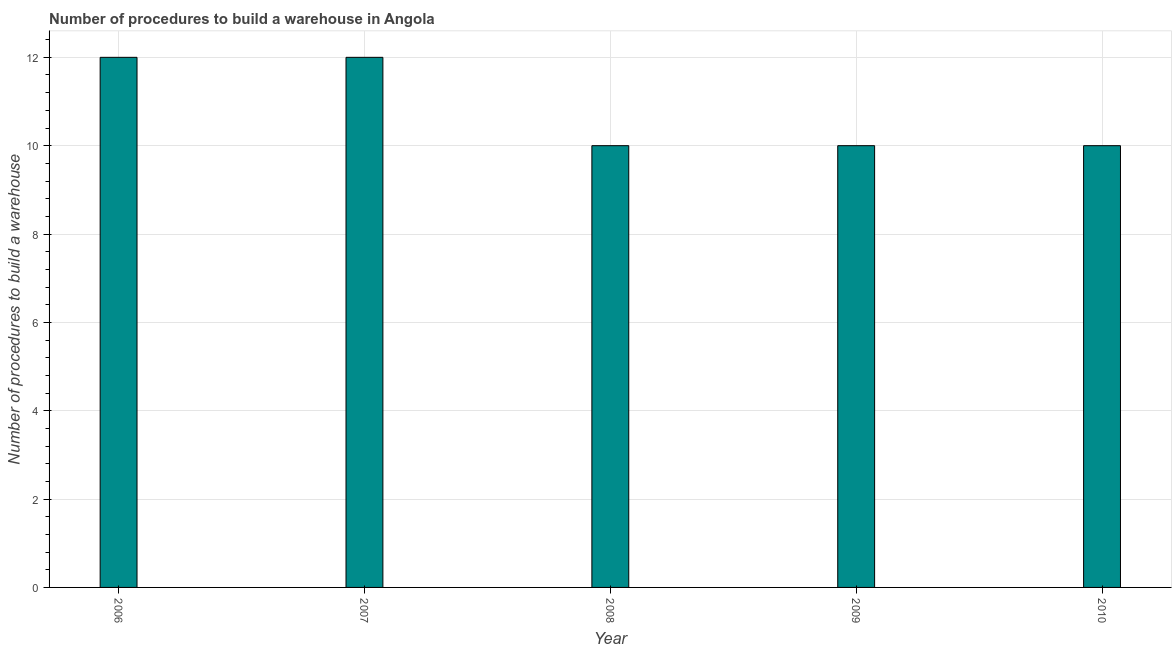Does the graph contain any zero values?
Offer a terse response. No. What is the title of the graph?
Provide a short and direct response. Number of procedures to build a warehouse in Angola. What is the label or title of the X-axis?
Ensure brevity in your answer.  Year. What is the label or title of the Y-axis?
Offer a very short reply. Number of procedures to build a warehouse. What is the number of procedures to build a warehouse in 2007?
Give a very brief answer. 12. Across all years, what is the maximum number of procedures to build a warehouse?
Provide a succinct answer. 12. What is the sum of the number of procedures to build a warehouse?
Keep it short and to the point. 54. What is the average number of procedures to build a warehouse per year?
Offer a very short reply. 10. What is the median number of procedures to build a warehouse?
Give a very brief answer. 10. In how many years, is the number of procedures to build a warehouse greater than 9.6 ?
Your answer should be compact. 5. What is the ratio of the number of procedures to build a warehouse in 2007 to that in 2009?
Give a very brief answer. 1.2. Is the number of procedures to build a warehouse in 2006 less than that in 2010?
Your answer should be very brief. No. Is the sum of the number of procedures to build a warehouse in 2007 and 2008 greater than the maximum number of procedures to build a warehouse across all years?
Your response must be concise. Yes. What is the difference between two consecutive major ticks on the Y-axis?
Ensure brevity in your answer.  2. Are the values on the major ticks of Y-axis written in scientific E-notation?
Keep it short and to the point. No. What is the Number of procedures to build a warehouse in 2010?
Keep it short and to the point. 10. What is the difference between the Number of procedures to build a warehouse in 2006 and 2007?
Your response must be concise. 0. What is the difference between the Number of procedures to build a warehouse in 2006 and 2008?
Offer a terse response. 2. What is the difference between the Number of procedures to build a warehouse in 2007 and 2009?
Give a very brief answer. 2. What is the difference between the Number of procedures to build a warehouse in 2008 and 2009?
Make the answer very short. 0. What is the difference between the Number of procedures to build a warehouse in 2008 and 2010?
Your answer should be compact. 0. What is the difference between the Number of procedures to build a warehouse in 2009 and 2010?
Give a very brief answer. 0. What is the ratio of the Number of procedures to build a warehouse in 2006 to that in 2010?
Give a very brief answer. 1.2. What is the ratio of the Number of procedures to build a warehouse in 2008 to that in 2009?
Your response must be concise. 1. 